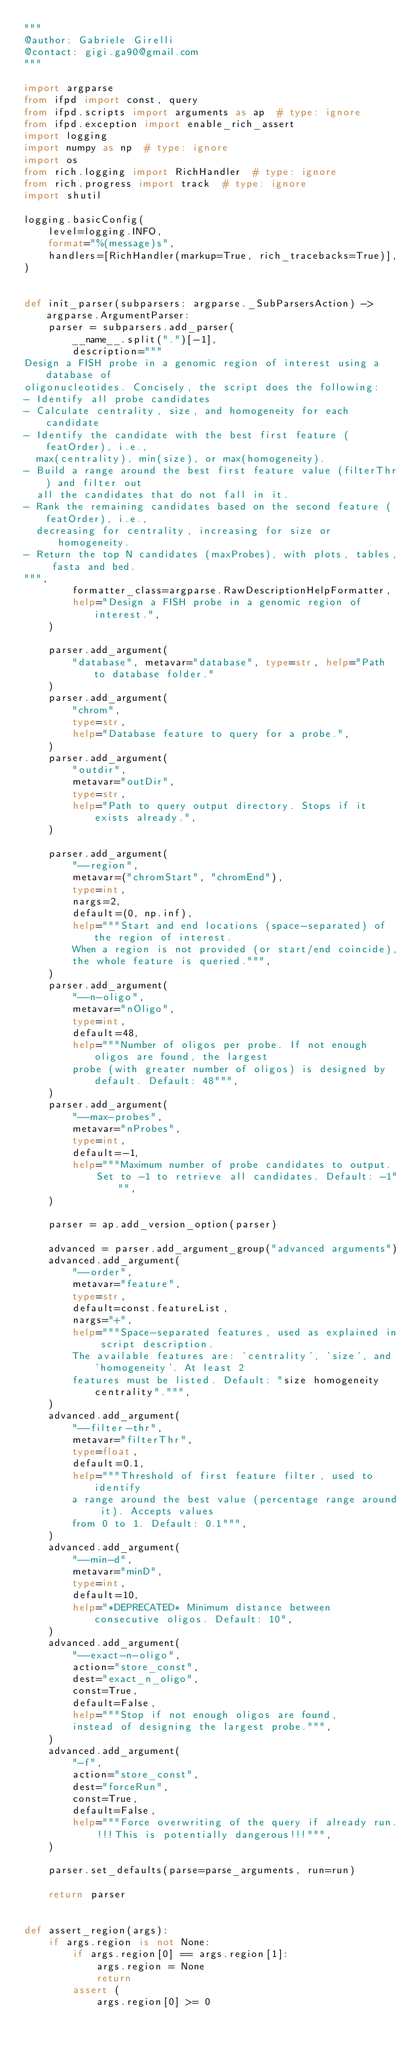<code> <loc_0><loc_0><loc_500><loc_500><_Python_>"""
@author: Gabriele Girelli
@contact: gigi.ga90@gmail.com
"""

import argparse
from ifpd import const, query
from ifpd.scripts import arguments as ap  # type: ignore
from ifpd.exception import enable_rich_assert
import logging
import numpy as np  # type: ignore
import os
from rich.logging import RichHandler  # type: ignore
from rich.progress import track  # type: ignore
import shutil

logging.basicConfig(
    level=logging.INFO,
    format="%(message)s",
    handlers=[RichHandler(markup=True, rich_tracebacks=True)],
)


def init_parser(subparsers: argparse._SubParsersAction) -> argparse.ArgumentParser:
    parser = subparsers.add_parser(
        __name__.split(".")[-1],
        description="""
Design a FISH probe in a genomic region of interest using a database of
oligonucleotides. Concisely, the script does the following:
- Identify all probe candidates
- Calculate centrality, size, and homogeneity for each candidate
- Identify the candidate with the best first feature (featOrder), i.e.,
  max(centrality), min(size), or max(homogeneity).
- Build a range around the best first feature value (filterThr) and filter out
  all the candidates that do not fall in it.
- Rank the remaining candidates based on the second feature (featOrder), i.e.,
  decreasing for centrality, increasing for size or homogeneity.
- Return the top N candidates (maxProbes), with plots, tables, fasta and bed.
""",
        formatter_class=argparse.RawDescriptionHelpFormatter,
        help="Design a FISH probe in a genomic region of interest.",
    )

    parser.add_argument(
        "database", metavar="database", type=str, help="Path to database folder."
    )
    parser.add_argument(
        "chrom",
        type=str,
        help="Database feature to query for a probe.",
    )
    parser.add_argument(
        "outdir",
        metavar="outDir",
        type=str,
        help="Path to query output directory. Stops if it exists already.",
    )

    parser.add_argument(
        "--region",
        metavar=("chromStart", "chromEnd"),
        type=int,
        nargs=2,
        default=(0, np.inf),
        help="""Start and end locations (space-separated) of the region of interest.
        When a region is not provided (or start/end coincide),
        the whole feature is queried.""",
    )
    parser.add_argument(
        "--n-oligo",
        metavar="nOligo",
        type=int,
        default=48,
        help="""Number of oligos per probe. If not enough oligos are found, the largest
        probe (with greater number of oligos) is designed by default. Default: 48""",
    )
    parser.add_argument(
        "--max-probes",
        metavar="nProbes",
        type=int,
        default=-1,
        help="""Maximum number of probe candidates to output.
            Set to -1 to retrieve all candidates. Default: -1""",
    )

    parser = ap.add_version_option(parser)

    advanced = parser.add_argument_group("advanced arguments")
    advanced.add_argument(
        "--order",
        metavar="feature",
        type=str,
        default=const.featureList,
        nargs="+",
        help="""Space-separated features, used as explained in script description.
        The available features are: 'centrality', 'size', and 'homogeneity'. At least 2
        features must be listed. Default: "size homogeneity centrality".""",
    )
    advanced.add_argument(
        "--filter-thr",
        metavar="filterThr",
        type=float,
        default=0.1,
        help="""Threshold of first feature filter, used to identify
        a range around the best value (percentage range around it). Accepts values
        from 0 to 1. Default: 0.1""",
    )
    advanced.add_argument(
        "--min-d",
        metavar="minD",
        type=int,
        default=10,
        help="*DEPRECATED* Minimum distance between consecutive oligos. Default: 10",
    )
    advanced.add_argument(
        "--exact-n-oligo",
        action="store_const",
        dest="exact_n_oligo",
        const=True,
        default=False,
        help="""Stop if not enough oligos are found,
        instead of designing the largest probe.""",
    )
    advanced.add_argument(
        "-f",
        action="store_const",
        dest="forceRun",
        const=True,
        default=False,
        help="""Force overwriting of the query if already run.
            !!!This is potentially dangerous!!!""",
    )

    parser.set_defaults(parse=parse_arguments, run=run)

    return parser


def assert_region(args):
    if args.region is not None:
        if args.region[0] == args.region[1]:
            args.region = None
            return
        assert (
            args.region[0] >= 0</code> 